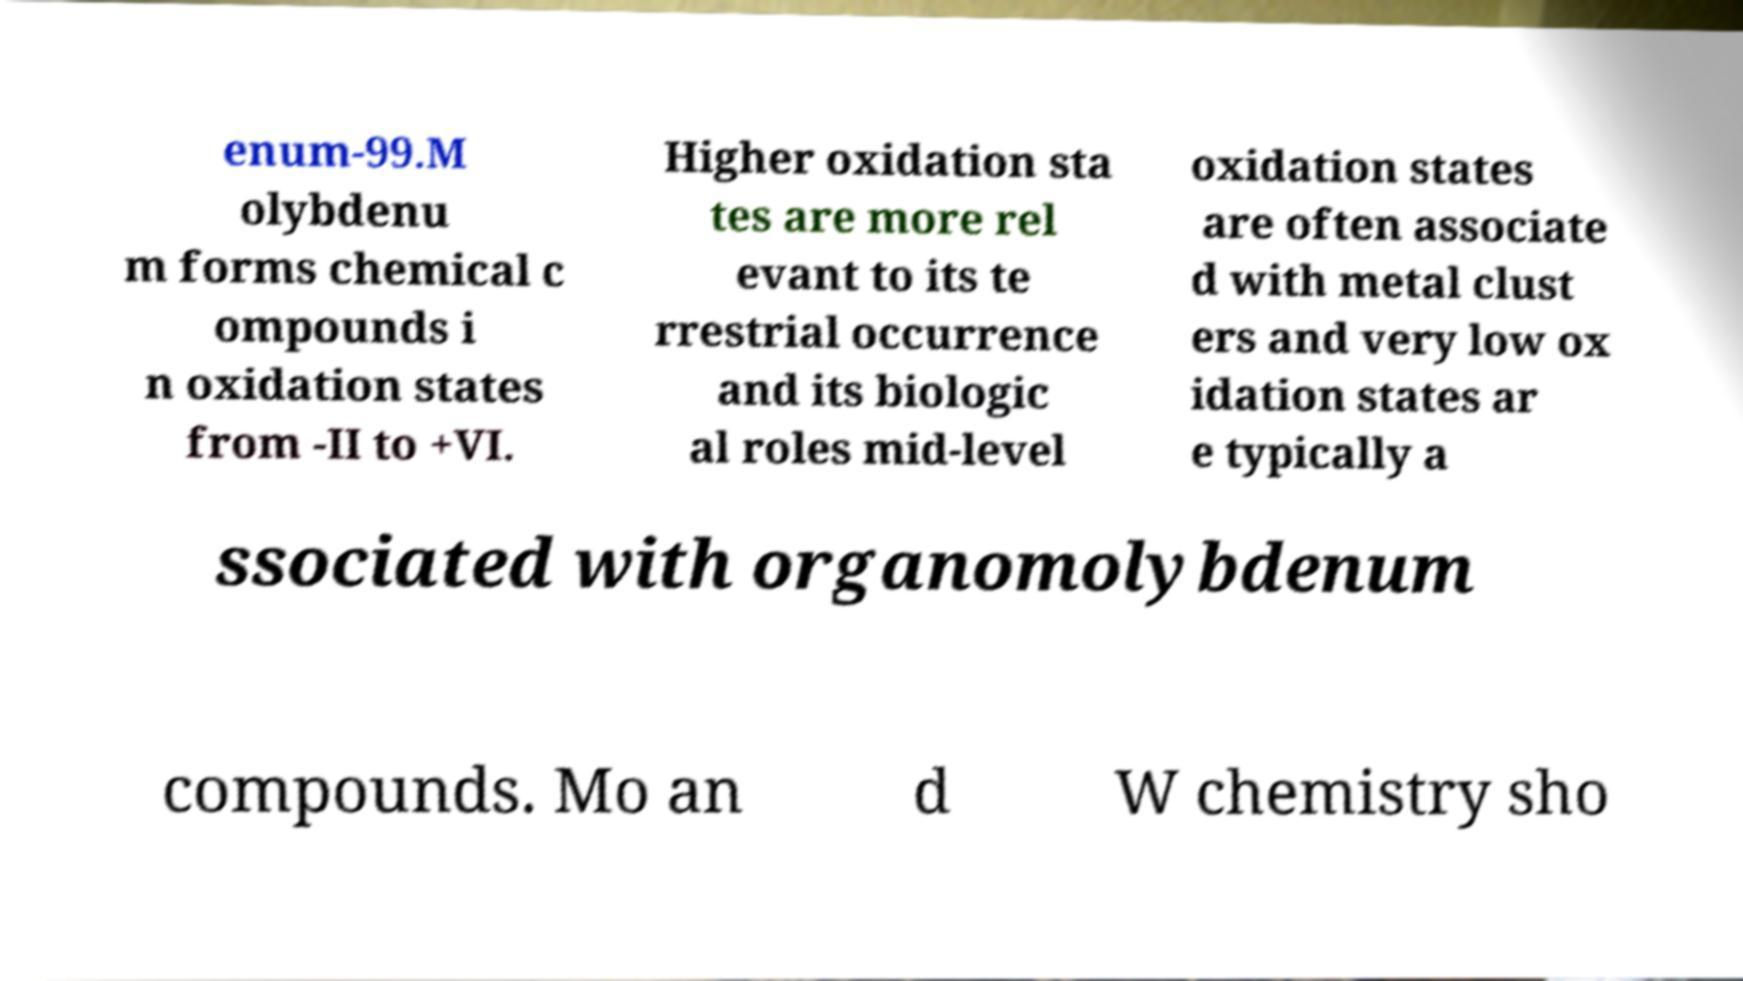For documentation purposes, I need the text within this image transcribed. Could you provide that? enum-99.M olybdenu m forms chemical c ompounds i n oxidation states from -II to +VI. Higher oxidation sta tes are more rel evant to its te rrestrial occurrence and its biologic al roles mid-level oxidation states are often associate d with metal clust ers and very low ox idation states ar e typically a ssociated with organomolybdenum compounds. Mo an d W chemistry sho 